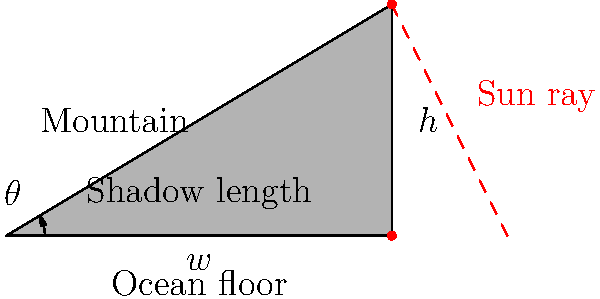During your underwater expedition, you encounter an intriguing underwater mountain near a hydrothermal vent field. Using your submersible's sonar, you measure the shadow length of the mountain on the ocean floor to be 500 meters. The angle between the ocean floor and the sun's rays is measured to be 35°. Calculate the height of the underwater mountain. To solve this problem, we can use trigonometry, specifically the tangent function. Let's break it down step-by-step:

1) In a right triangle, tangent of an angle is the ratio of the opposite side to the adjacent side.

   $\tan(\theta) = \frac{\text{opposite}}{\text{adjacent}} = \frac{\text{height}}{\text{shadow length}}$

2) We are given:
   - Shadow length (adjacent side) = 500 meters
   - Angle $\theta$ = 35°

3) We need to find the height (opposite side). Let's call it $h$.

4) Using the tangent function:

   $\tan(35°) = \frac{h}{500}$

5) To solve for $h$, multiply both sides by 500:

   $500 \cdot \tan(35°) = h$

6) Now, let's calculate:
   
   $h = 500 \cdot \tan(35°)$
   
   $h = 500 \cdot 0.7002075382$ (using a calculator)
   
   $h \approx 350.10$ meters

Therefore, the height of the underwater mountain is approximately 350.10 meters.
Answer: 350.10 meters 